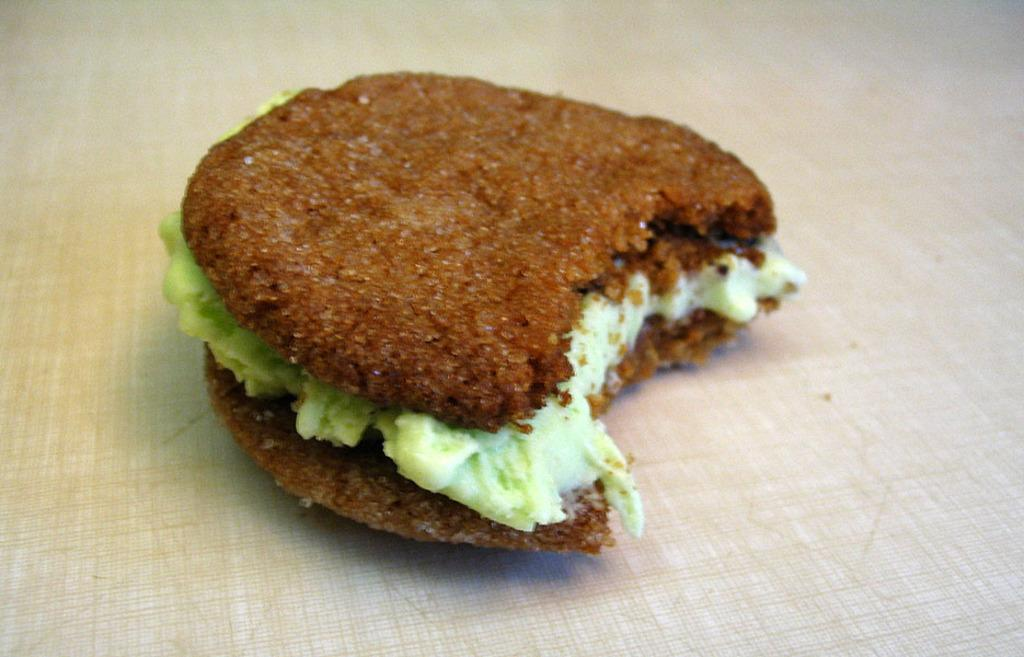What type of food is shown in the image? There is a burger in the image. What is the color of the surface the burger is on? The burger is on a white surface. How does the burger's growth rate compare to that of a plant in the image? There is no plant present in the image, so it is not possible to compare the growth rate of the burger to that of a plant. 